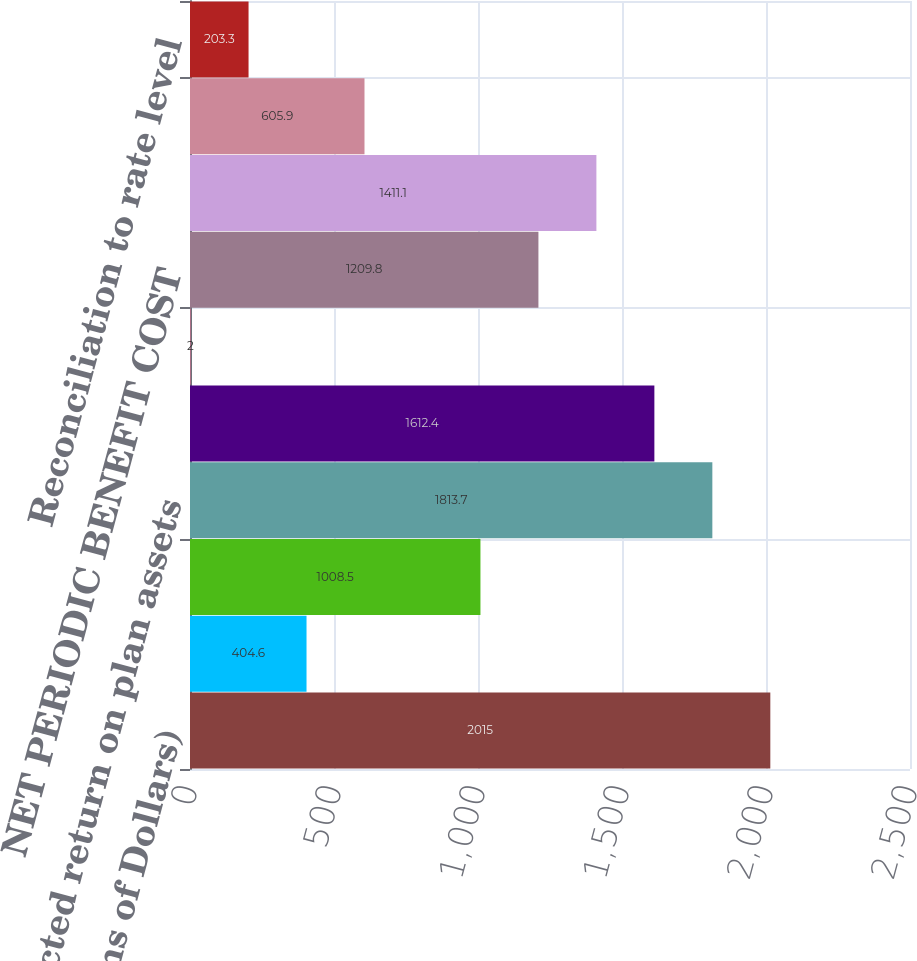Convert chart. <chart><loc_0><loc_0><loc_500><loc_500><bar_chart><fcel>(Millions of Dollars)<fcel>Service cost - including<fcel>Interest cost on projected<fcel>Expected return on plan assets<fcel>Recognition of net actuarial<fcel>Recognition of prior service<fcel>NET PERIODIC BENEFIT COST<fcel>TOTAL PERIODIC BENEFIT COST<fcel>Cost capitalized<fcel>Reconciliation to rate level<nl><fcel>2015<fcel>404.6<fcel>1008.5<fcel>1813.7<fcel>1612.4<fcel>2<fcel>1209.8<fcel>1411.1<fcel>605.9<fcel>203.3<nl></chart> 